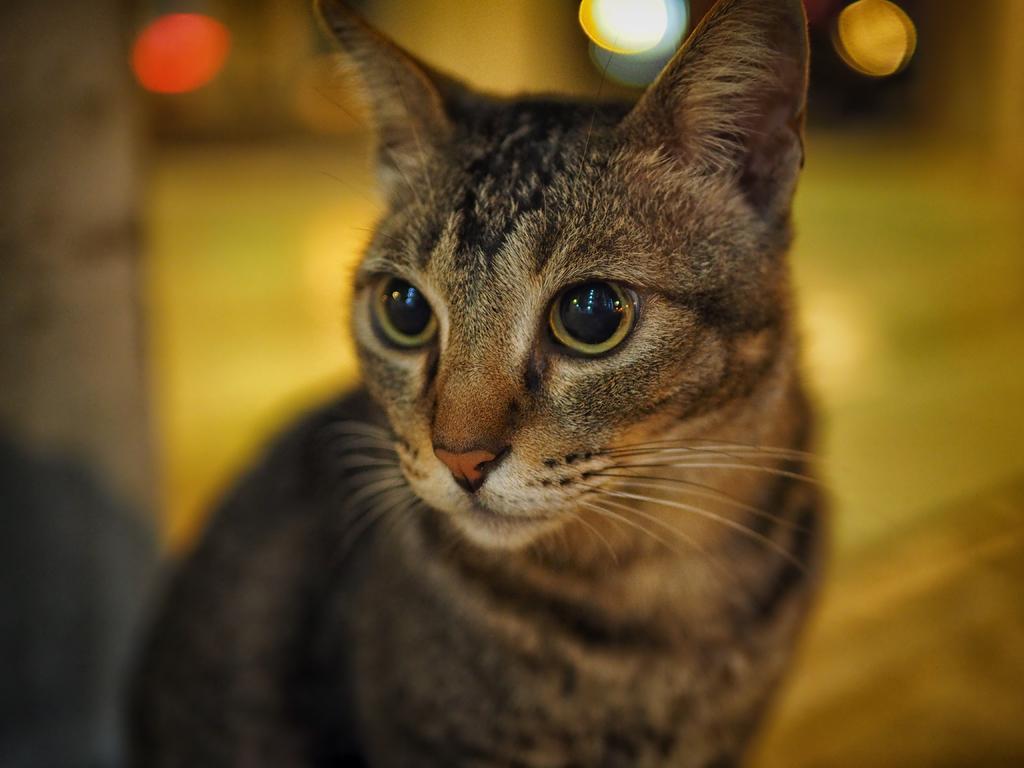Please provide a concise description of this image. This image consists of a cat in brown color. In the background, there are lights. And the background is blurred. 